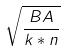Convert formula to latex. <formula><loc_0><loc_0><loc_500><loc_500>\sqrt { \frac { B A } { k * n } }</formula> 